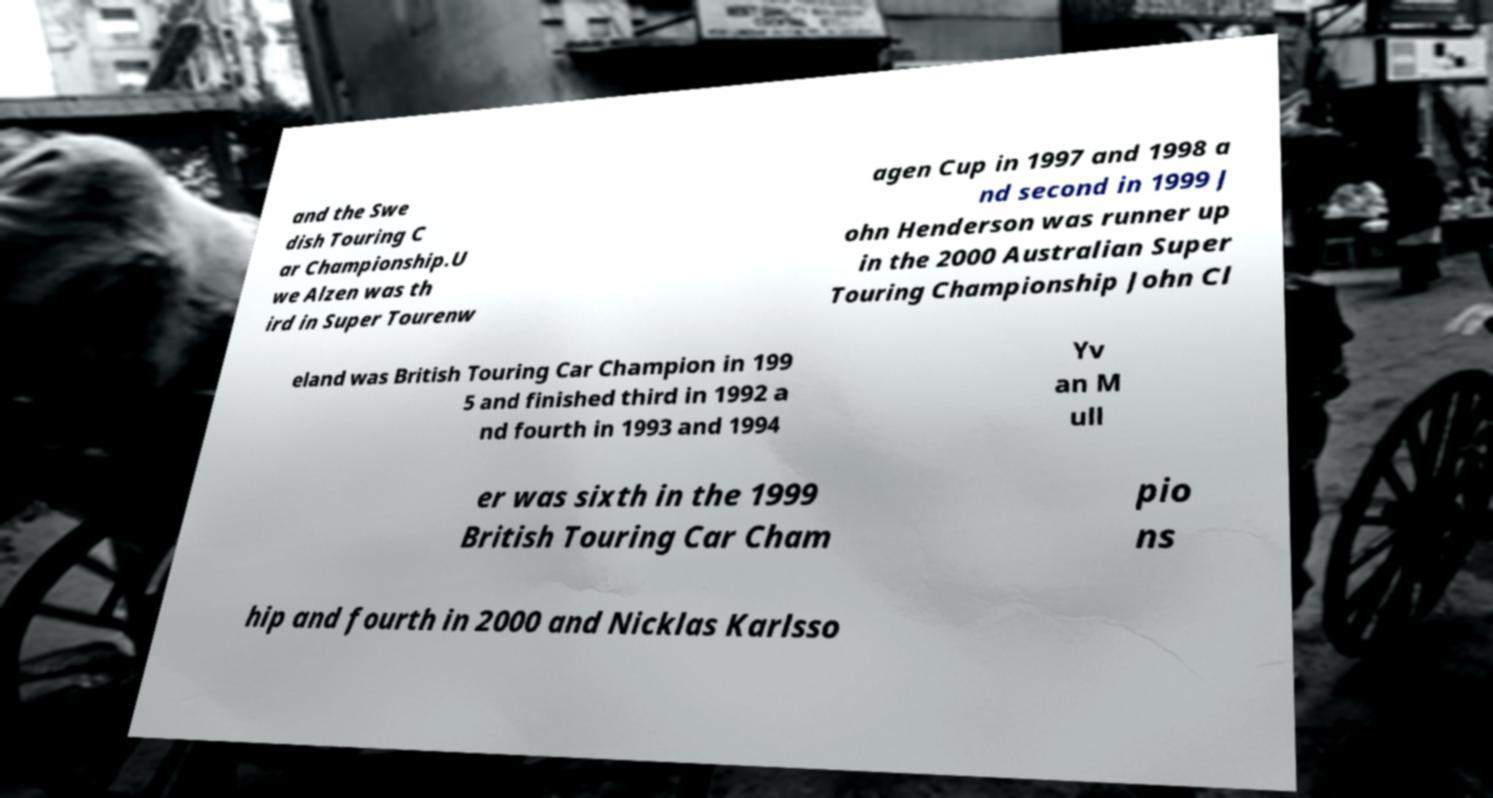Could you extract and type out the text from this image? and the Swe dish Touring C ar Championship.U we Alzen was th ird in Super Tourenw agen Cup in 1997 and 1998 a nd second in 1999 J ohn Henderson was runner up in the 2000 Australian Super Touring Championship John Cl eland was British Touring Car Champion in 199 5 and finished third in 1992 a nd fourth in 1993 and 1994 Yv an M ull er was sixth in the 1999 British Touring Car Cham pio ns hip and fourth in 2000 and Nicklas Karlsso 